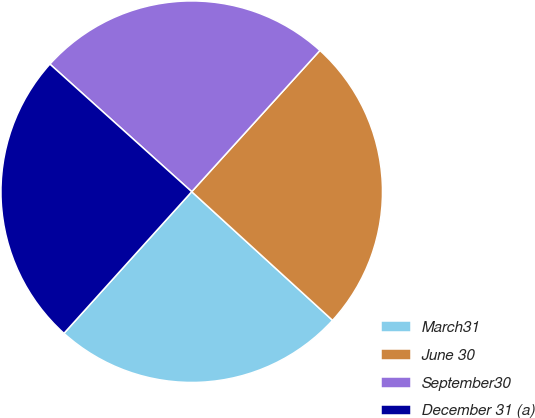Convert chart to OTSL. <chart><loc_0><loc_0><loc_500><loc_500><pie_chart><fcel>March31<fcel>June 30<fcel>September30<fcel>December 31 (a)<nl><fcel>24.9%<fcel>25.05%<fcel>25.07%<fcel>24.98%<nl></chart> 